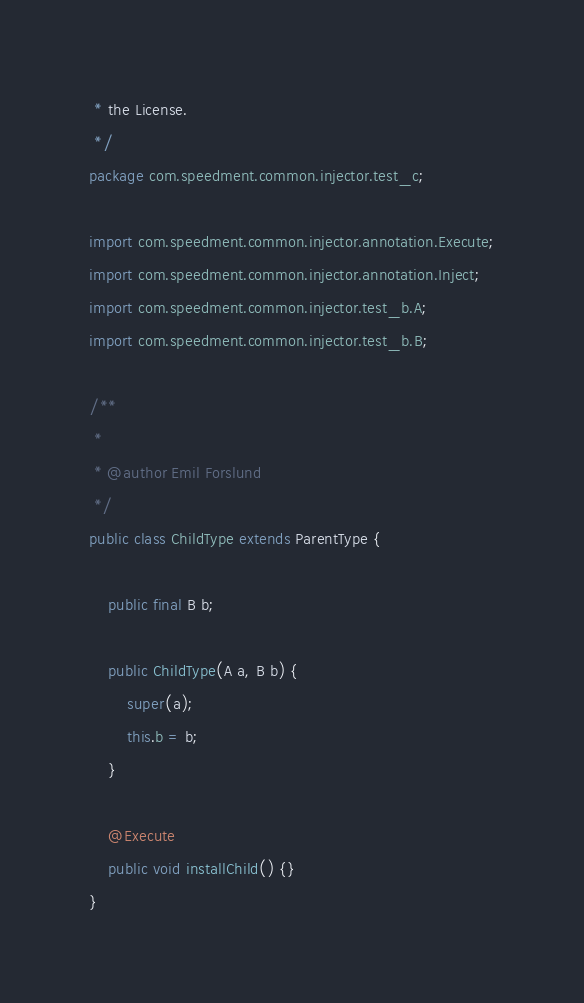<code> <loc_0><loc_0><loc_500><loc_500><_Java_> * the License.
 */
package com.speedment.common.injector.test_c;

import com.speedment.common.injector.annotation.Execute;
import com.speedment.common.injector.annotation.Inject;
import com.speedment.common.injector.test_b.A;
import com.speedment.common.injector.test_b.B;

/**
 *
 * @author Emil Forslund
 */
public class ChildType extends ParentType {
    
    public final B b;

    public ChildType(A a, B b) {
        super(a);
        this.b = b;
    }

    @Execute
    public void installChild() {}
}</code> 